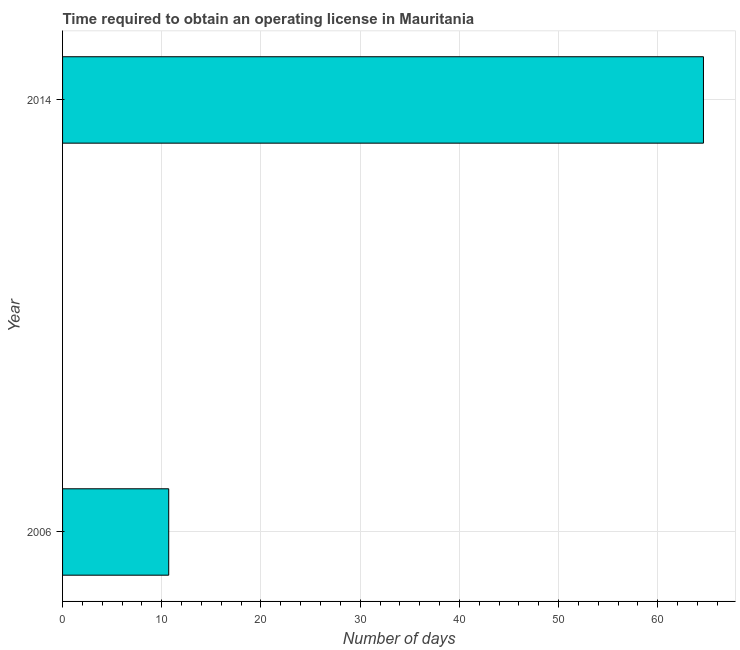Does the graph contain grids?
Give a very brief answer. Yes. What is the title of the graph?
Make the answer very short. Time required to obtain an operating license in Mauritania. What is the label or title of the X-axis?
Make the answer very short. Number of days. What is the number of days to obtain operating license in 2014?
Ensure brevity in your answer.  64.6. Across all years, what is the maximum number of days to obtain operating license?
Offer a terse response. 64.6. Across all years, what is the minimum number of days to obtain operating license?
Your answer should be very brief. 10.7. In which year was the number of days to obtain operating license maximum?
Your answer should be very brief. 2014. What is the sum of the number of days to obtain operating license?
Provide a succinct answer. 75.3. What is the difference between the number of days to obtain operating license in 2006 and 2014?
Provide a succinct answer. -53.9. What is the average number of days to obtain operating license per year?
Ensure brevity in your answer.  37.65. What is the median number of days to obtain operating license?
Your answer should be compact. 37.65. What is the ratio of the number of days to obtain operating license in 2006 to that in 2014?
Your answer should be compact. 0.17. In how many years, is the number of days to obtain operating license greater than the average number of days to obtain operating license taken over all years?
Provide a short and direct response. 1. How many bars are there?
Offer a very short reply. 2. What is the difference between two consecutive major ticks on the X-axis?
Ensure brevity in your answer.  10. Are the values on the major ticks of X-axis written in scientific E-notation?
Your response must be concise. No. What is the Number of days in 2006?
Offer a very short reply. 10.7. What is the Number of days of 2014?
Your answer should be compact. 64.6. What is the difference between the Number of days in 2006 and 2014?
Ensure brevity in your answer.  -53.9. What is the ratio of the Number of days in 2006 to that in 2014?
Keep it short and to the point. 0.17. 